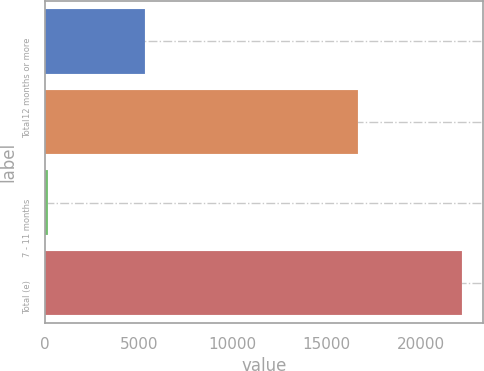Convert chart to OTSL. <chart><loc_0><loc_0><loc_500><loc_500><bar_chart><fcel>12 months or more<fcel>Total<fcel>7 - 11 months<fcel>Total (e)<nl><fcel>5323<fcel>16653<fcel>193<fcel>22224<nl></chart> 